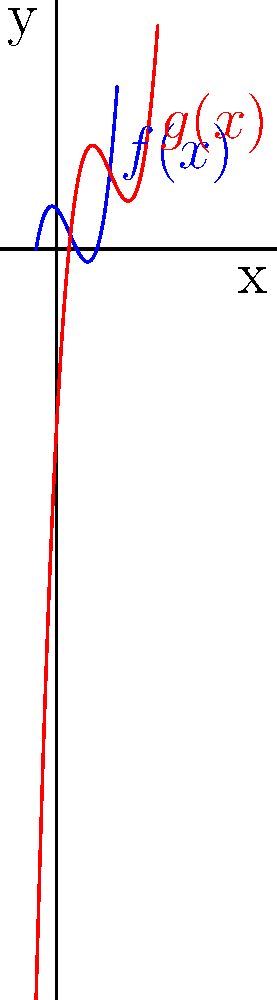Consider the polynomial function $f(x)=x^3-2x^2-x+2$ and its transformation $g(x)=f(x-2)+3$. How does this transformation affect the y-intercept of the function? Relate your answer to Dr. Anthony Neal's concept of "transformation" in African American philosophical thought. To solve this problem, let's follow these steps:

1) First, we need to find the y-intercept of $f(x)$:
   The y-intercept is the value of $f(x)$ when $x=0$.
   $f(0) = 0^3 - 2(0)^2 - 0 + 2 = 2$

2) Now, let's consider the transformation $g(x) = f(x-2) + 3$:
   - $(x-2)$ shifts the function 2 units to the right
   - $+3$ shifts the function 3 units up

3) To find the y-intercept of $g(x)$, we need to calculate $g(0)$:
   $g(0) = f(0-2) + 3 = f(-2) + 3$

4) Calculate $f(-2)$:
   $f(-2) = (-2)^3 - 2(-2)^2 - (-2) + 2$
          $= -8 - 8 + 2 + 2$
          $= -12$

5) Therefore, $g(0) = f(-2) + 3 = -12 + 3 = -9$

6) Comparing the y-intercepts:
   $f(x)$ has a y-intercept of 2
   $g(x)$ has a y-intercept of -9

7) The difference between these y-intercepts is: $-9 - 2 = -11$

This transformation can be related to Dr. Anthony Neal's concept of "transformation" in African American philosophical thought. Just as the function undergoes a shift that fundamentally changes its relationship to the origin (y-intercept), Neal argues that African American philosophy involves a transformation of Western philosophical concepts to address the unique experiences and perspectives of African Americans.
Answer: The transformation decreases the y-intercept by 11 units. 